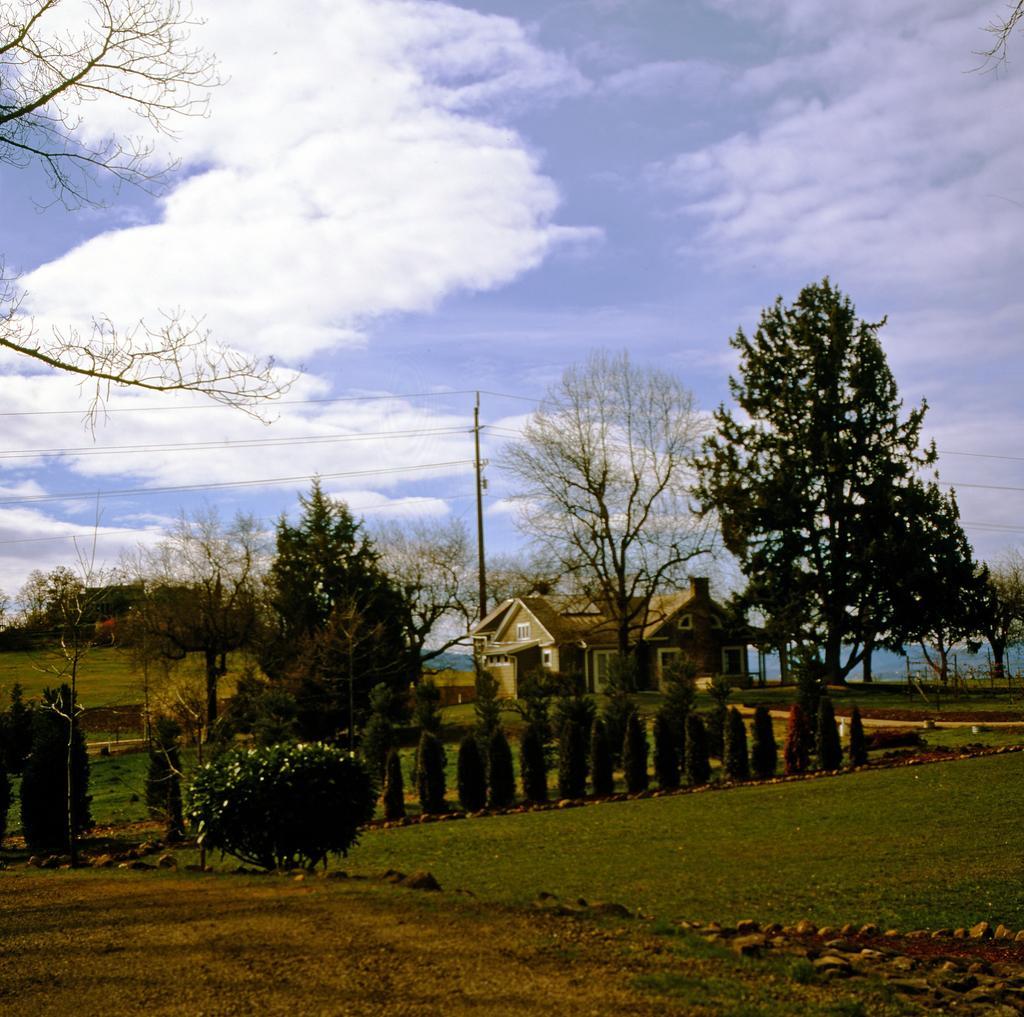Describe this image in one or two sentences. In this image there is a house in the middle. There are trees around it. At the top there is the sky. At the bottom there is ground on which there are stones and small grass. In front of the house there is a garden in which there are plants. 